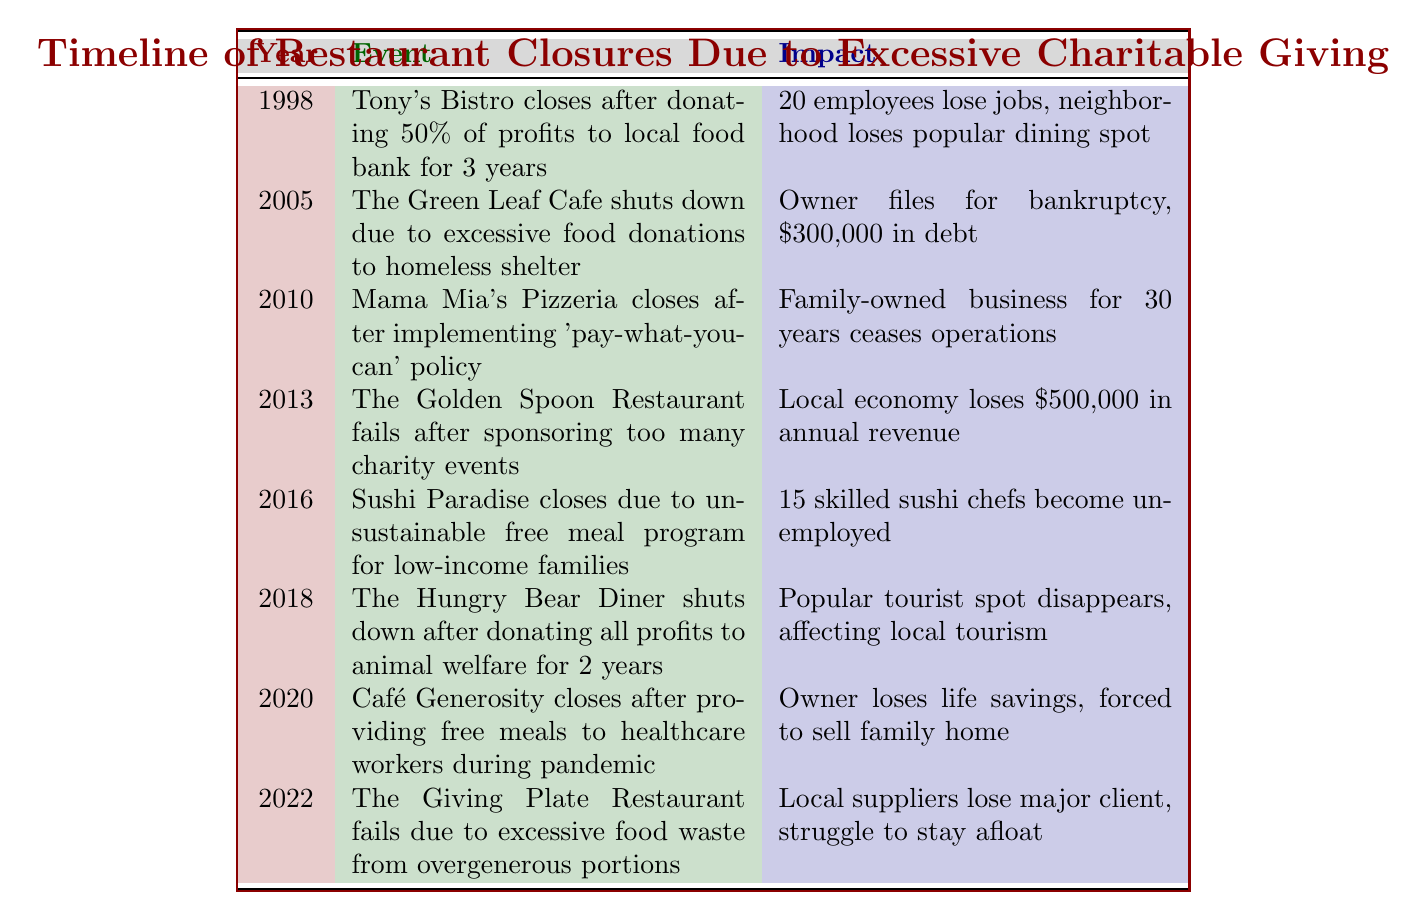What year did Tony's Bistro close? The table indicates that Tony's Bistro closed in the year 1998
Answer: 1998 How many employees lost their jobs when Sushi Paradise closed? According to the table, 15 skilled sushi chefs became unemployed when Sushi Paradise closed
Answer: 15 What is the total debt reported for The Green Leaf Cafe? The table states that the owner of The Green Leaf Cafe filed for bankruptcy and had $300,000 in debt
Answer: 300,000 Did Mama Mia's Pizzeria have a pay-what-you-can policy before closing? Yes, the table confirms that Mama Mia's Pizzeria closed after implementing a 'pay-what-you-can' policy
Answer: Yes Which restaurant had the highest reported local economic impact? By reviewing the impacts listed, The Golden Spoon Restaurant caused a local economy loss of $500,000, which is the highest impact among the events
Answer: $500,000 What is the difference in the number of jobs lost between Tony's Bistro and The Hungry Bear Diner? Tony's Bistro resulted in 20 job losses while The Hungry Bear Diner's closure had an impact on local tourism but did not specifically list job losses. Since we can't determine a numeric comparison for The Hungry Bear Diner, the difference cannot be calculated
Answer: Not applicable Which year saw two restaurant closures related to charitable activities? The years 2018 and 2020 both saw restaurant closures due to charitable giving: The Hungry Bear Diner and Café Generosity, respectively
Answer: 2018 and 2020 What was the primary reason for the closure of The Giving Plate Restaurant? The closure of The Giving Plate Restaurant was due to excessive food waste resulting from overgenerous portions, as stated in the table
Answer: Excessive food waste from overgenerous portions What percentage of profits did Tony's Bistro donate before it closed? The table indicates that Tony's Bistro donated 50% of its profits to a local food bank for three years before closing
Answer: 50% 